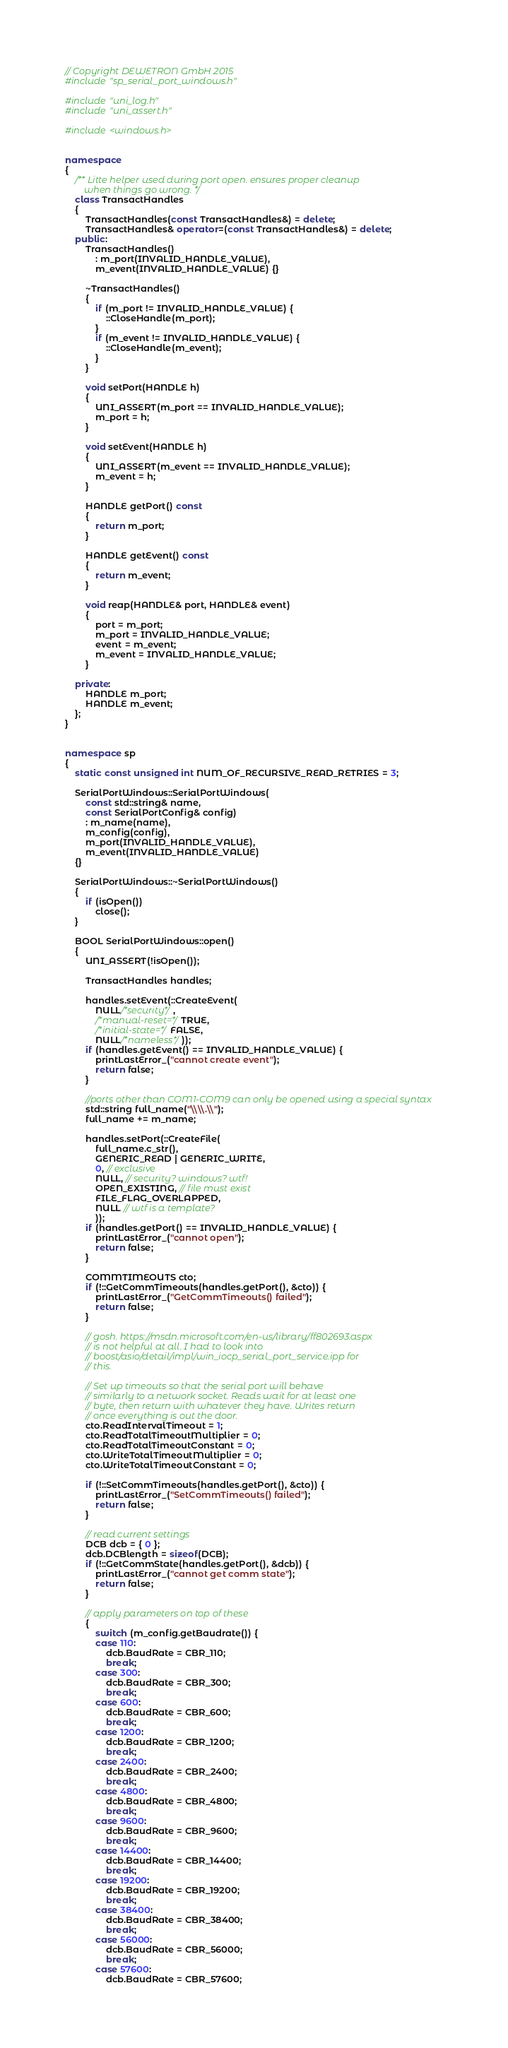Convert code to text. <code><loc_0><loc_0><loc_500><loc_500><_C++_>// Copyright DEWETRON GmbH 2015
#include "sp_serial_port_windows.h"

#include "uni_log.h"
#include "uni_assert.h"

#include <windows.h>


namespace
{
    /** Litte helper used during port open. ensures proper cleanup
        when things go wrong. */
    class TransactHandles
    {
        TransactHandles(const TransactHandles&) = delete;
        TransactHandles& operator=(const TransactHandles&) = delete;
    public:
        TransactHandles()
            : m_port(INVALID_HANDLE_VALUE),
            m_event(INVALID_HANDLE_VALUE) {}

        ~TransactHandles()
        {
            if (m_port != INVALID_HANDLE_VALUE) {
                ::CloseHandle(m_port);
            }
            if (m_event != INVALID_HANDLE_VALUE) {
                ::CloseHandle(m_event);
            }
        }

        void setPort(HANDLE h)
        {
            UNI_ASSERT(m_port == INVALID_HANDLE_VALUE);
            m_port = h;
        }

        void setEvent(HANDLE h)
        {
            UNI_ASSERT(m_event == INVALID_HANDLE_VALUE);
            m_event = h;
        }

        HANDLE getPort() const
        {
            return m_port;
        }

        HANDLE getEvent() const
        {
            return m_event;
        }

        void reap(HANDLE& port, HANDLE& event)
        {
            port = m_port;
            m_port = INVALID_HANDLE_VALUE;
            event = m_event;
            m_event = INVALID_HANDLE_VALUE;
        }

    private:
        HANDLE m_port;
        HANDLE m_event;
    };
}


namespace sp
{
    static const unsigned int NUM_OF_RECURSIVE_READ_RETRIES = 3;

    SerialPortWindows::SerialPortWindows(
        const std::string& name,
        const SerialPortConfig& config)
        : m_name(name),
        m_config(config),
        m_port(INVALID_HANDLE_VALUE),
        m_event(INVALID_HANDLE_VALUE)
    {}

    SerialPortWindows::~SerialPortWindows()
    {
        if (isOpen())
            close();
    }

    BOOL SerialPortWindows::open()
    {
        UNI_ASSERT(!isOpen());

        TransactHandles handles;

        handles.setEvent(::CreateEvent(
            NULL/*security*/,
            /*manual-reset=*/TRUE,
            /*initial-state=*/FALSE,
            NULL/*nameless*/));
        if (handles.getEvent() == INVALID_HANDLE_VALUE) {
            printLastError_("cannot create event");
            return false;
        }

        //ports other than COM1-COM9 can only be opened using a special syntax
        std::string full_name("\\\\.\\");
        full_name += m_name;

        handles.setPort(::CreateFile(
            full_name.c_str(),
            GENERIC_READ | GENERIC_WRITE,
            0, // exclusive
            NULL, // security? windows? wtf!
            OPEN_EXISTING, // file must exist
            FILE_FLAG_OVERLAPPED,
            NULL // wtf is a template?
            ));
        if (handles.getPort() == INVALID_HANDLE_VALUE) {
            printLastError_("cannot open");
            return false;
        }

        COMMTIMEOUTS cto;
        if (!::GetCommTimeouts(handles.getPort(), &cto)) {
            printLastError_("GetCommTimeouts() failed");
            return false;
        }

        // gosh. https://msdn.microsoft.com/en-us/library/ff802693.aspx
        // is not helpful at all. I had to look into
        // boost/asio/detail/impl/win_iocp_serial_port_service.ipp for
        // this.

        // Set up timeouts so that the serial port will behave
        // similarly to a network socket. Reads wait for at least one
        // byte, then return with whatever they have. Writes return
        // once everything is out the door.
        cto.ReadIntervalTimeout = 1;
        cto.ReadTotalTimeoutMultiplier = 0;
        cto.ReadTotalTimeoutConstant = 0;
        cto.WriteTotalTimeoutMultiplier = 0;
        cto.WriteTotalTimeoutConstant = 0;

        if (!::SetCommTimeouts(handles.getPort(), &cto)) {
            printLastError_("SetCommTimeouts() failed");
            return false;
        }

        // read current settings
        DCB dcb = { 0 };
        dcb.DCBlength = sizeof(DCB);
        if (!::GetCommState(handles.getPort(), &dcb)) {
            printLastError_("cannot get comm state");
            return false;
        }

        // apply parameters on top of these
        {
            switch (m_config.getBaudrate()) {
            case 110:
                dcb.BaudRate = CBR_110;
                break;
            case 300:
                dcb.BaudRate = CBR_300;
                break;
            case 600:
                dcb.BaudRate = CBR_600;
                break;
            case 1200:
                dcb.BaudRate = CBR_1200;
                break;
            case 2400:
                dcb.BaudRate = CBR_2400;
                break;
            case 4800:
                dcb.BaudRate = CBR_4800;
                break;
            case 9600:
                dcb.BaudRate = CBR_9600;
                break;
            case 14400:
                dcb.BaudRate = CBR_14400;
                break;
            case 19200:
                dcb.BaudRate = CBR_19200;
                break;
            case 38400:
                dcb.BaudRate = CBR_38400;
                break;
            case 56000:
                dcb.BaudRate = CBR_56000;
                break;
            case 57600:
                dcb.BaudRate = CBR_57600;</code> 